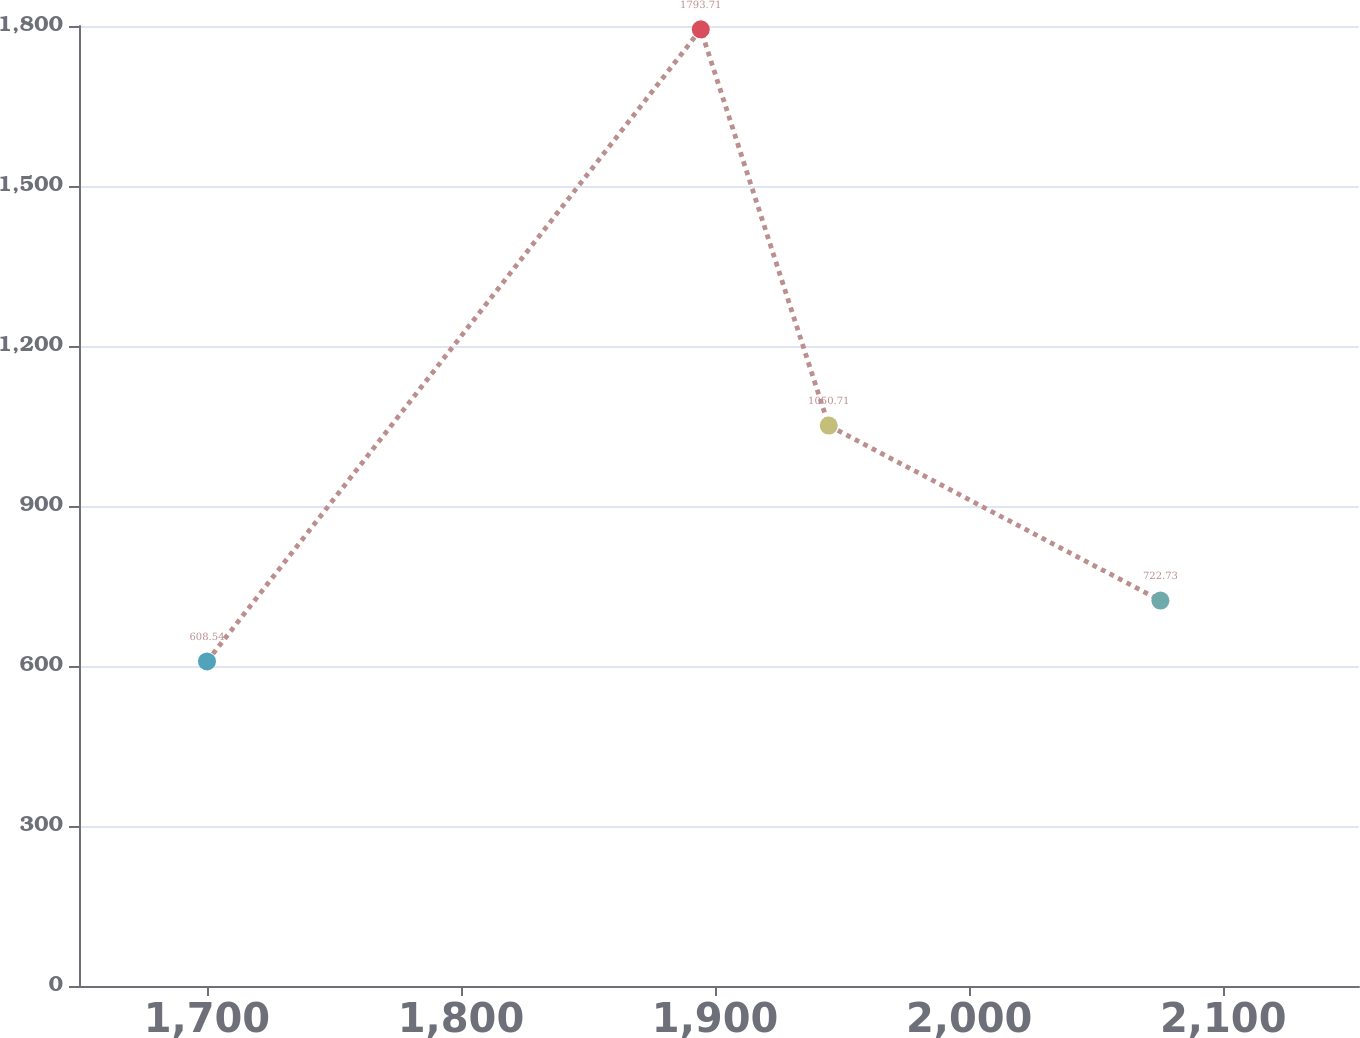Convert chart to OTSL. <chart><loc_0><loc_0><loc_500><loc_500><line_chart><ecel><fcel>Unnamed: 1<nl><fcel>1700.04<fcel>608.54<nl><fcel>1894.37<fcel>1793.71<nl><fcel>1944.75<fcel>1050.71<nl><fcel>2075.28<fcel>722.73<nl><fcel>2203.81<fcel>1679.52<nl></chart> 